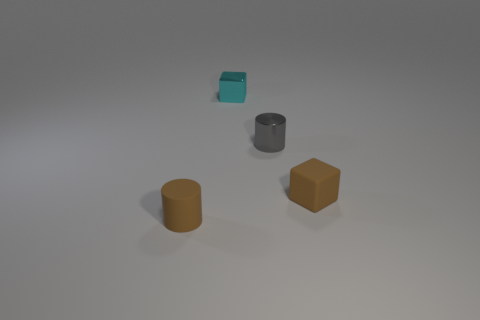Is there any indication of the size of these objects? Without a standard reference object for scale in the image, it is challenging to determine the precise size of these objects. However, based on their positioning and shadows, they appear to be of a size that could comfortably fit in an adult's hand. How might the lighting affect the perception of the objects' colors? The soft and diffuse lighting in the image ensures minimal glare, preserving the integrity of the objects' colors. However, subtle changes in lighting could potentially cause the colors to appear slightly different, for example, highlighting certain tones or casting shadows that might affect color perception. 